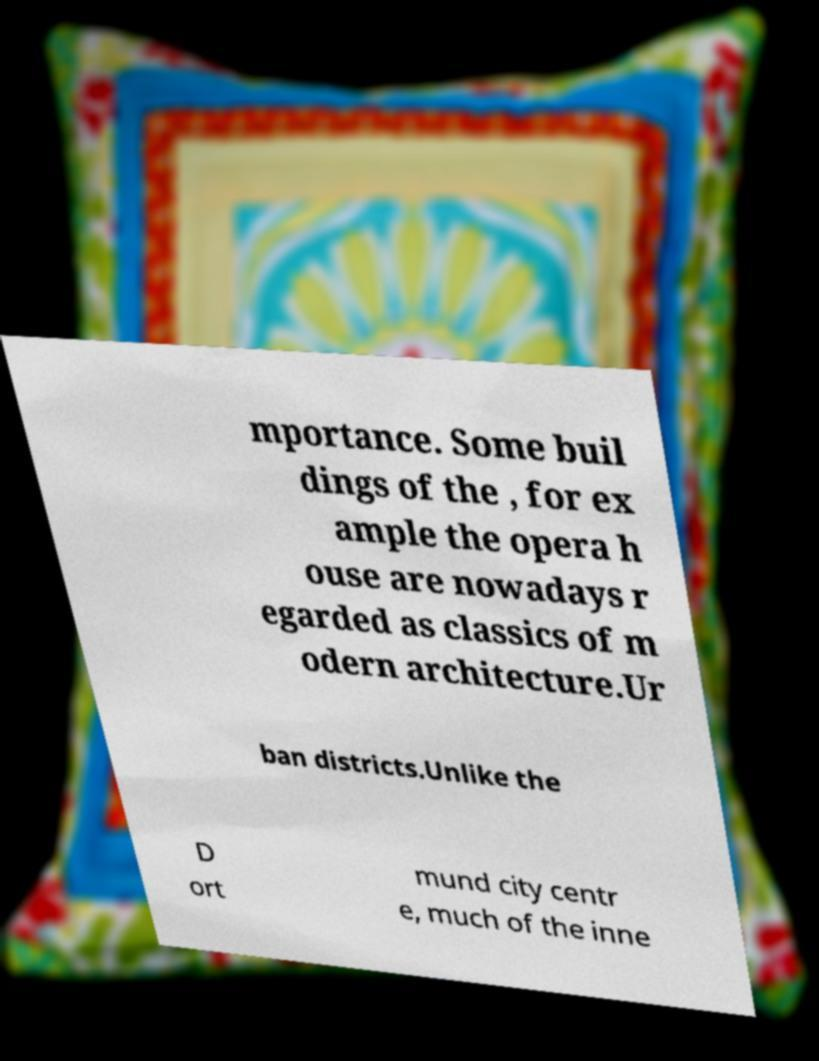Could you extract and type out the text from this image? mportance. Some buil dings of the , for ex ample the opera h ouse are nowadays r egarded as classics of m odern architecture.Ur ban districts.Unlike the D ort mund city centr e, much of the inne 